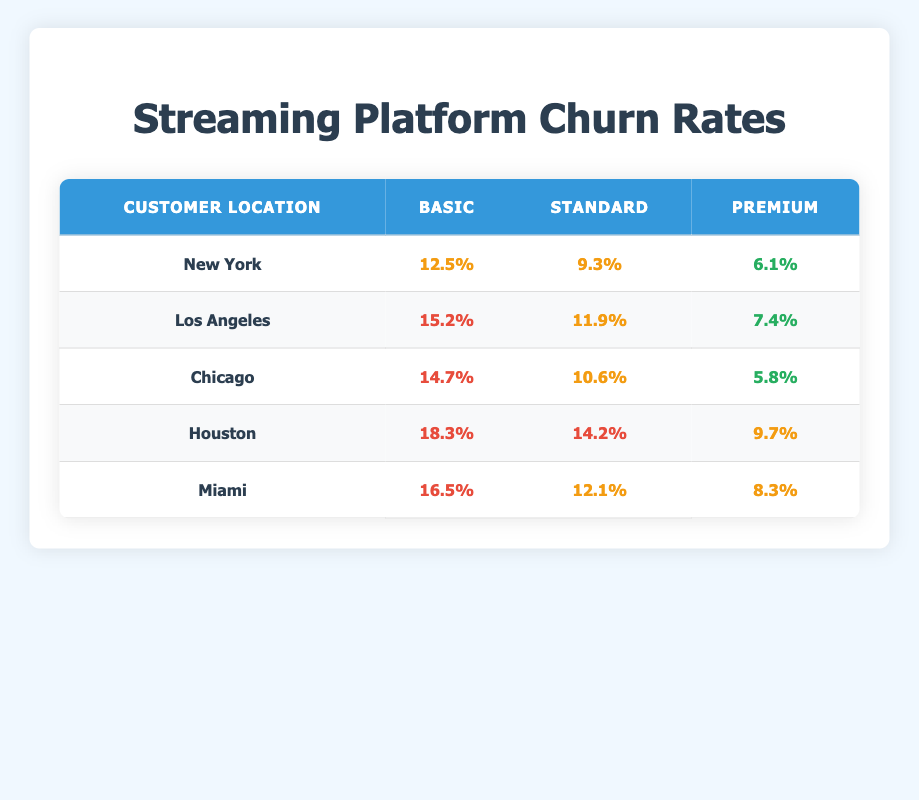What is the churn rate for the Premium subscription plan in New York? From the table, we look under New York in the Premium column, which shows a churn rate of 6.1%.
Answer: 6.1% Which customer location has the highest churn rate for the Basic subscription plan? By examining the Basic column for each location, we see that Houston has the highest churn rate at 18.3%.
Answer: Houston What is the average churn rate for the Standard subscription plan across all locations? We add the churn rates for the Standard plan: 9.3 (New York) + 11.9 (Los Angeles) + 10.6 (Chicago) + 14.2 (Houston) + 12.1 (Miami) = 58.1. Then divide by 5 (the number of locations), giving us an average of 11.62%.
Answer: 11.62% Is the churn rate for the Premium plan in Chicago lower than the churn rate for the Basic plan in Miami? The Premium plan churn rate in Chicago is 5.8% while the Basic plan churn rate in Miami is 16.5%. Since 5.8% is indeed lower than 16.5%, the statement is true.
Answer: Yes What is the difference in churn rates between the Basic and Premium plans in Los Angeles? The Basic plan churn rate in Los Angeles is 15.2%, and the Premium plan churn rate is 7.4%. The difference is calculated as 15.2 - 7.4 = 7.8%.
Answer: 7.8% 